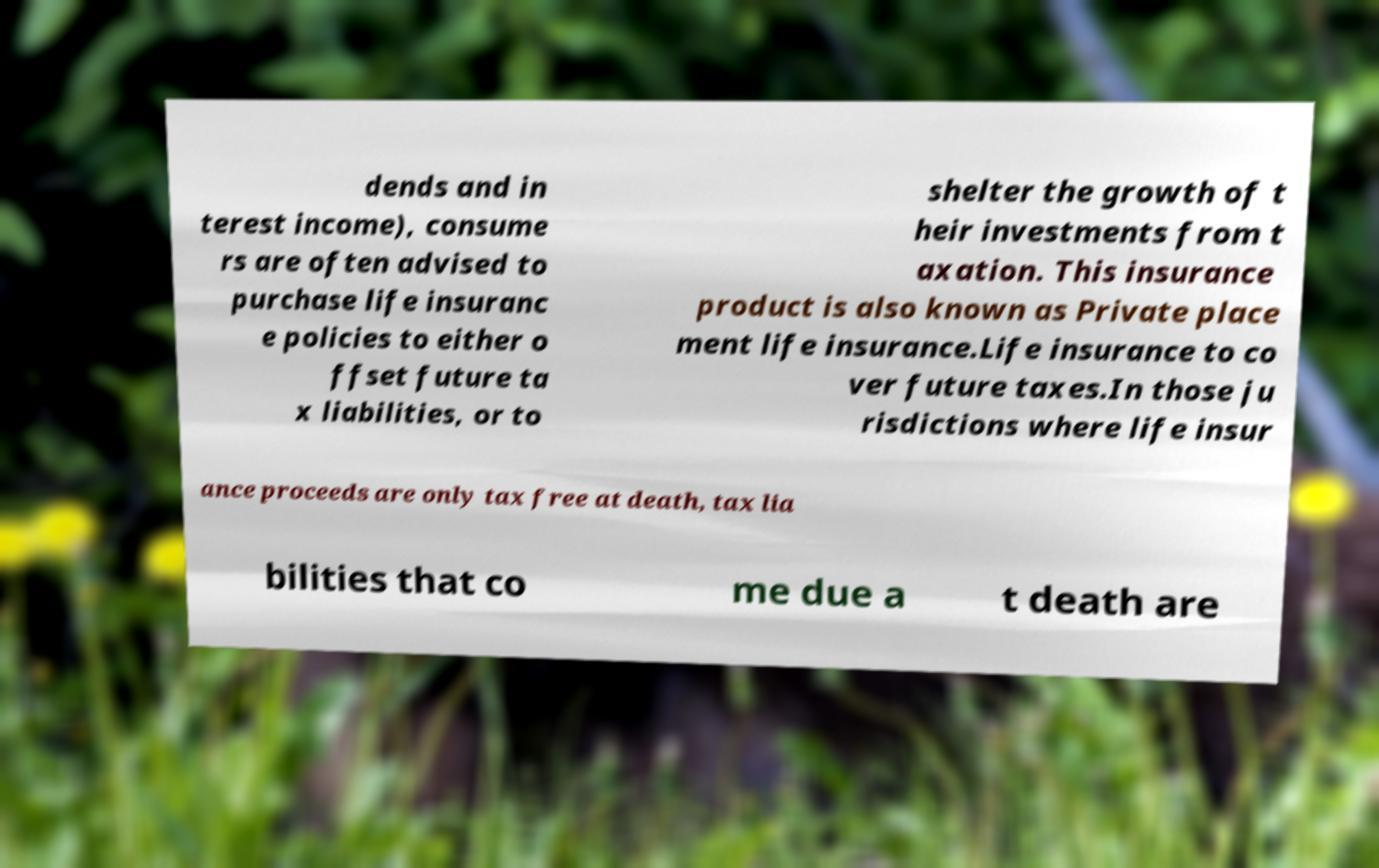I need the written content from this picture converted into text. Can you do that? dends and in terest income), consume rs are often advised to purchase life insuranc e policies to either o ffset future ta x liabilities, or to shelter the growth of t heir investments from t axation. This insurance product is also known as Private place ment life insurance.Life insurance to co ver future taxes.In those ju risdictions where life insur ance proceeds are only tax free at death, tax lia bilities that co me due a t death are 